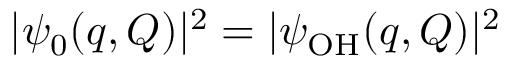Convert formula to latex. <formula><loc_0><loc_0><loc_500><loc_500>| \psi _ { 0 } ( q , Q ) | ^ { 2 } = | \psi _ { O H } ( q , Q ) | ^ { 2 }</formula> 